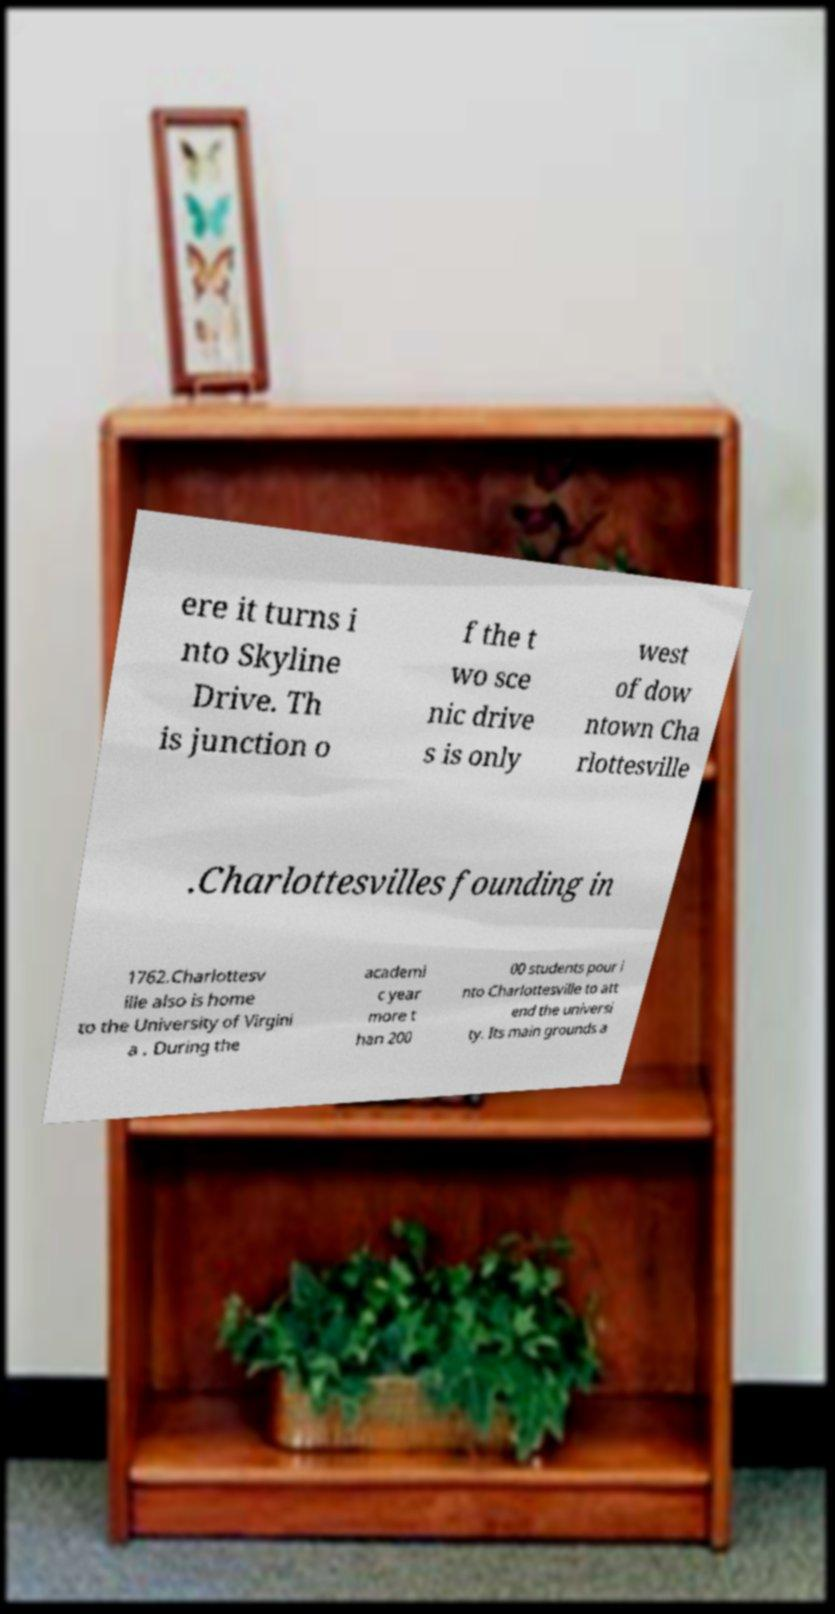Can you accurately transcribe the text from the provided image for me? ere it turns i nto Skyline Drive. Th is junction o f the t wo sce nic drive s is only west of dow ntown Cha rlottesville .Charlottesvilles founding in 1762.Charlottesv ille also is home to the University of Virgini a . During the academi c year more t han 200 00 students pour i nto Charlottesville to att end the universi ty. Its main grounds a 